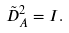Convert formula to latex. <formula><loc_0><loc_0><loc_500><loc_500>\tilde { D } _ { A } ^ { 2 } = I .</formula> 